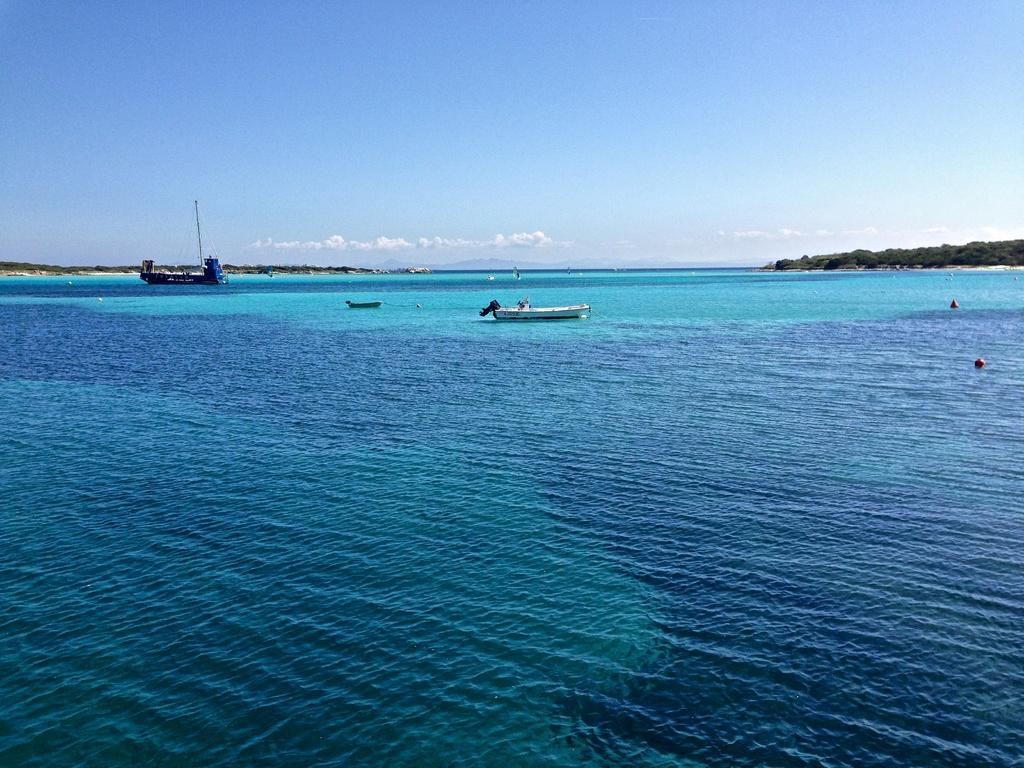What is the primary element in the image? There is water in the image. What is floating on the water in the image? There are boats in the image. What can be seen in the background of the image? The sky, trees, and clouds are visible in the background of the image. What type of pump is being used to cook the fish in the image? There is no pump or fish present in the image; it features water and boats. What color is the stocking on the person's leg in the image? There are no people or stockings present in the image. 